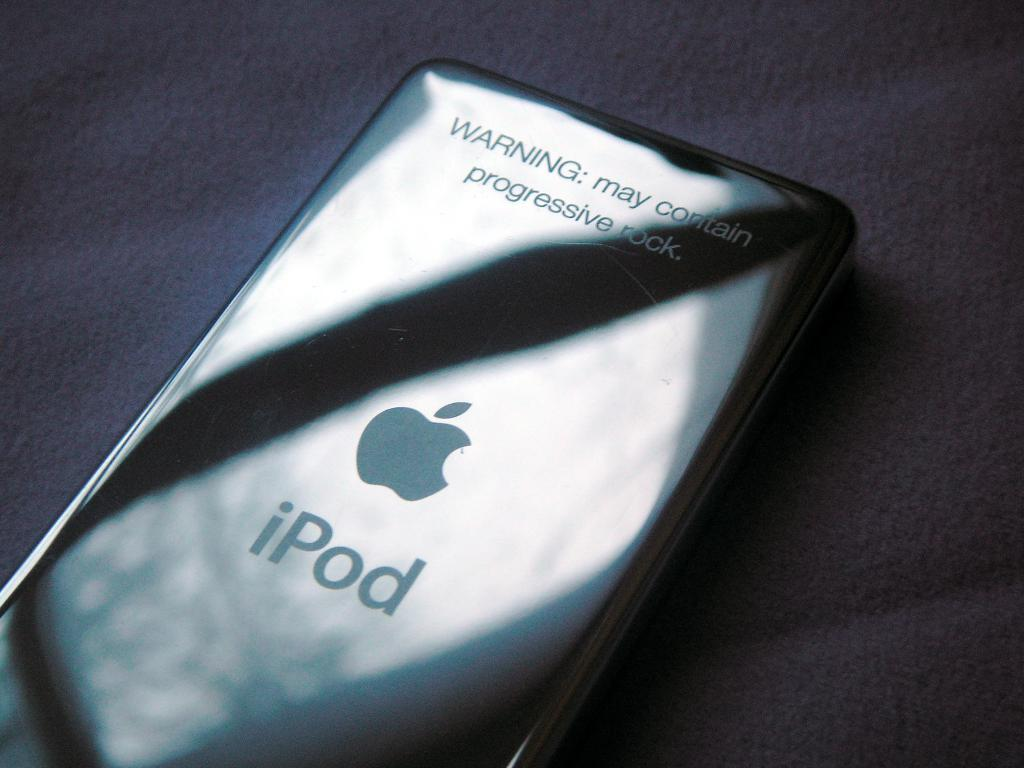<image>
Relay a brief, clear account of the picture shown. A silver iPod with a warning on the back of it. 